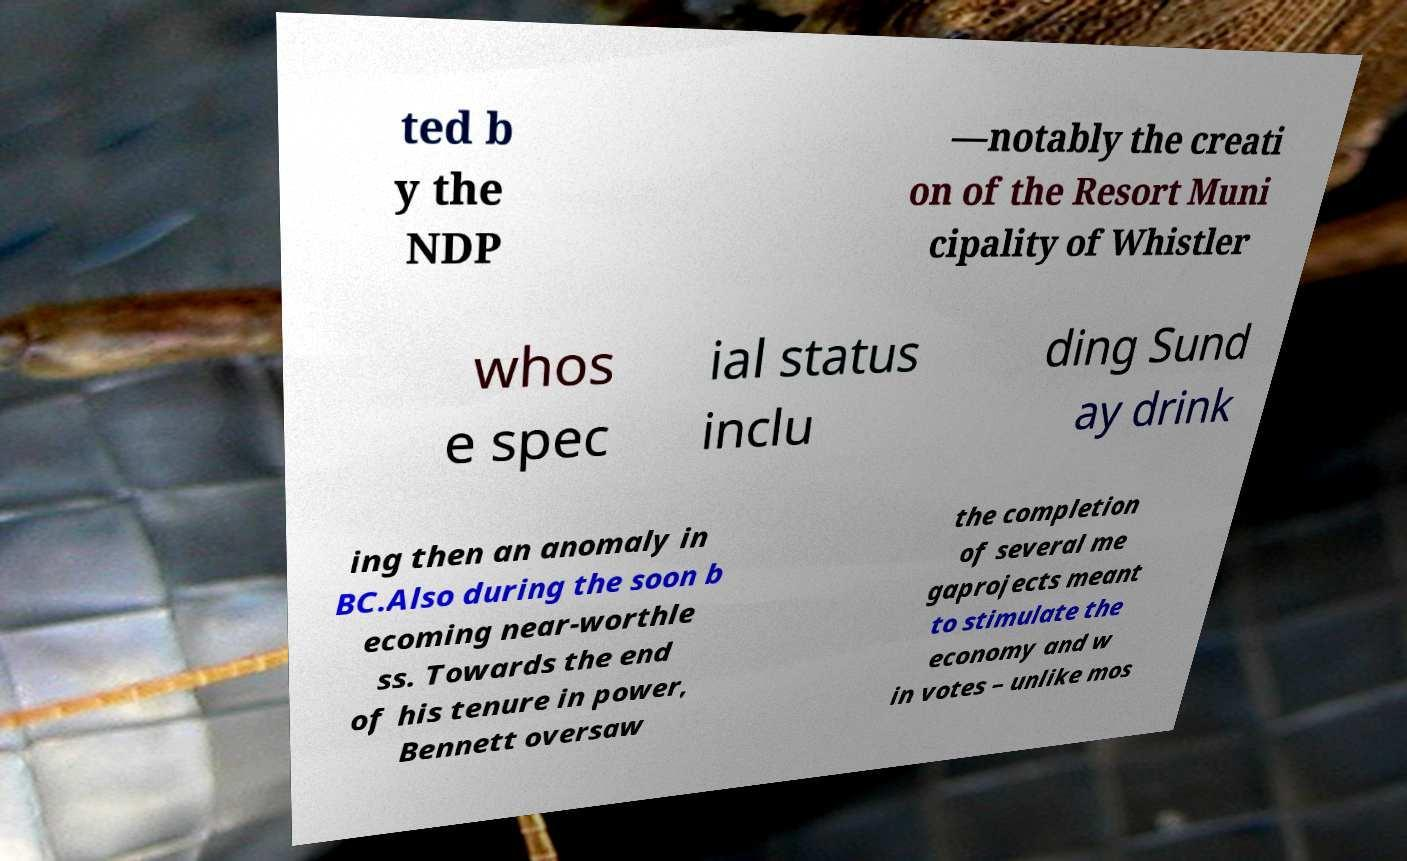Could you extract and type out the text from this image? ted b y the NDP —notably the creati on of the Resort Muni cipality of Whistler whos e spec ial status inclu ding Sund ay drink ing then an anomaly in BC.Also during the soon b ecoming near-worthle ss. Towards the end of his tenure in power, Bennett oversaw the completion of several me gaprojects meant to stimulate the economy and w in votes – unlike mos 